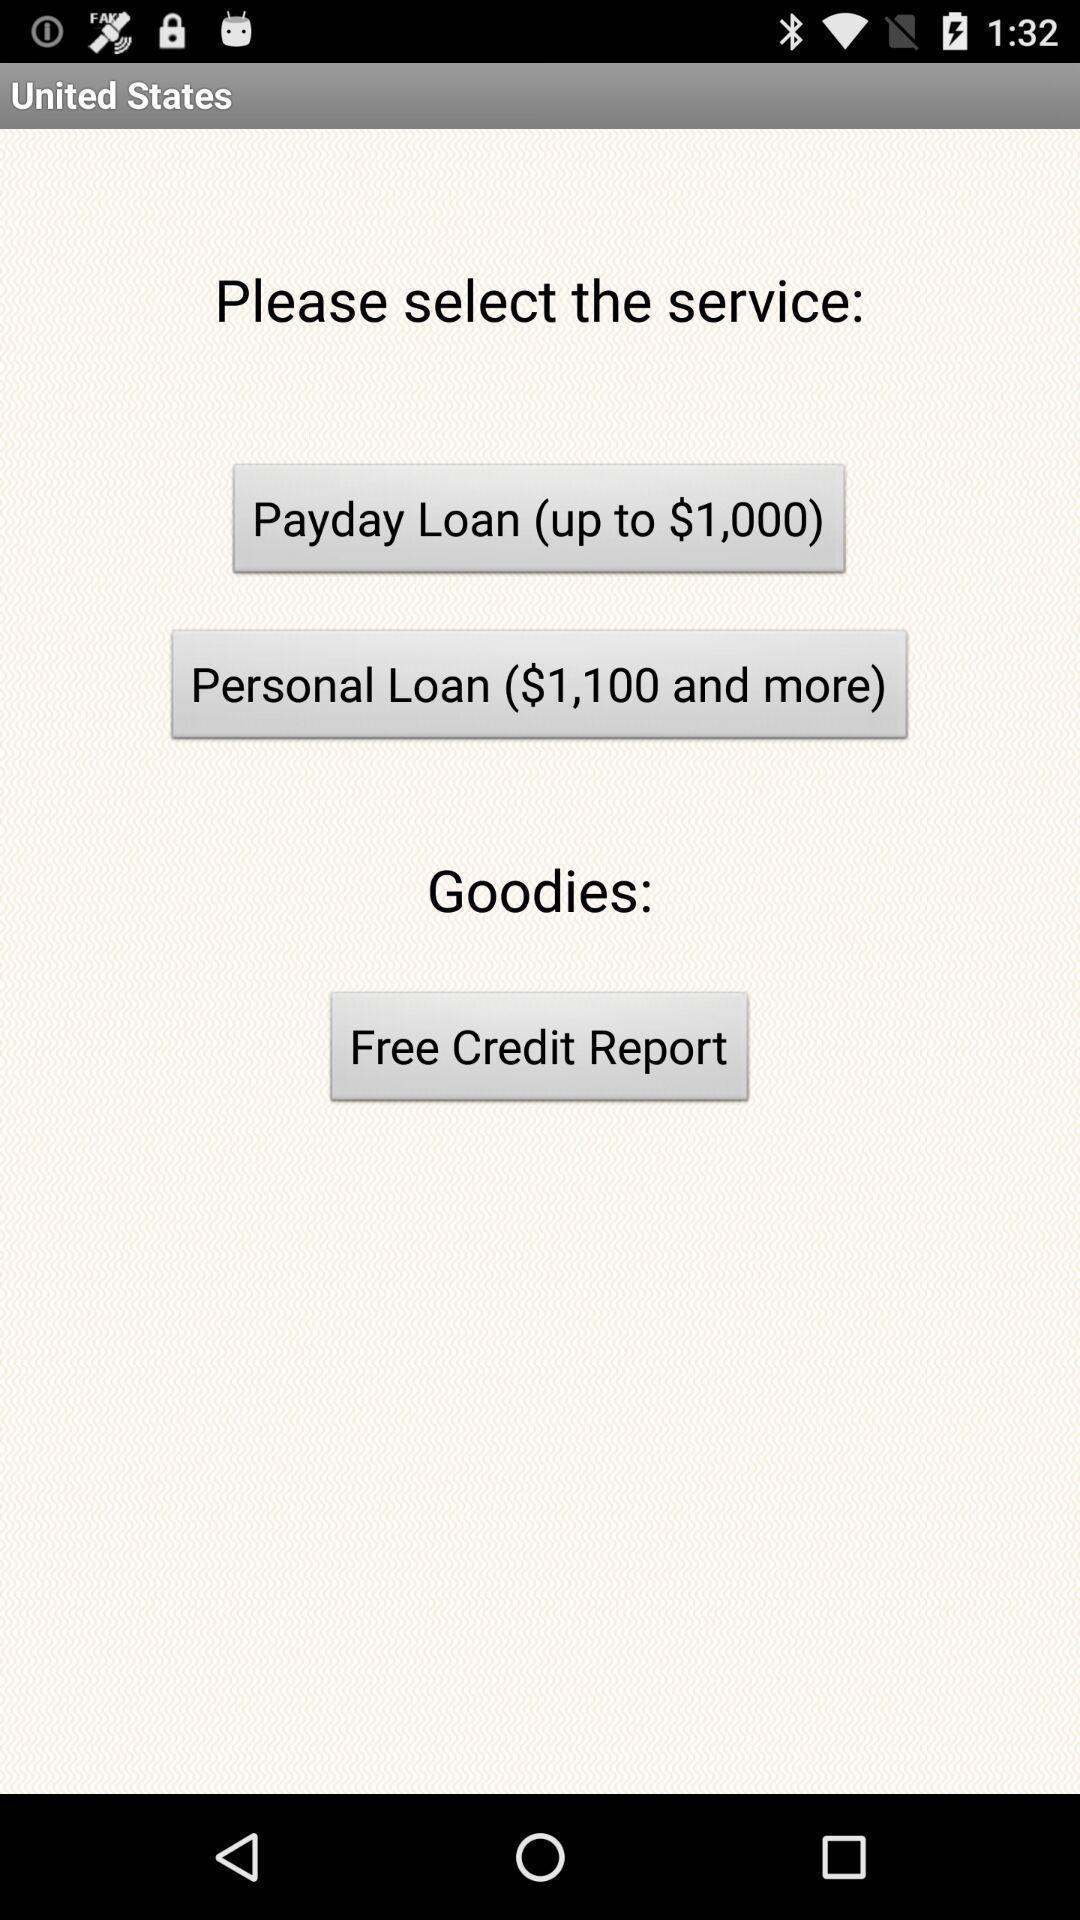Provide a textual representation of this image. Page shows the various services to choose on finance app. 